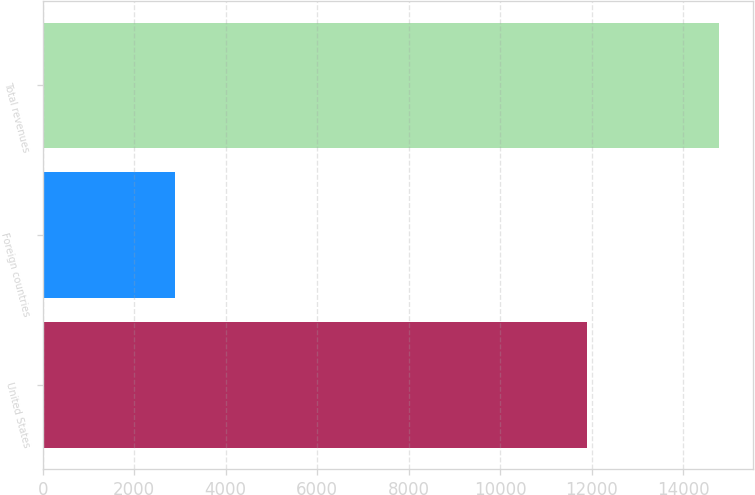<chart> <loc_0><loc_0><loc_500><loc_500><bar_chart><fcel>United States<fcel>Foreign countries<fcel>Total revenues<nl><fcel>11887<fcel>2884<fcel>14771<nl></chart> 